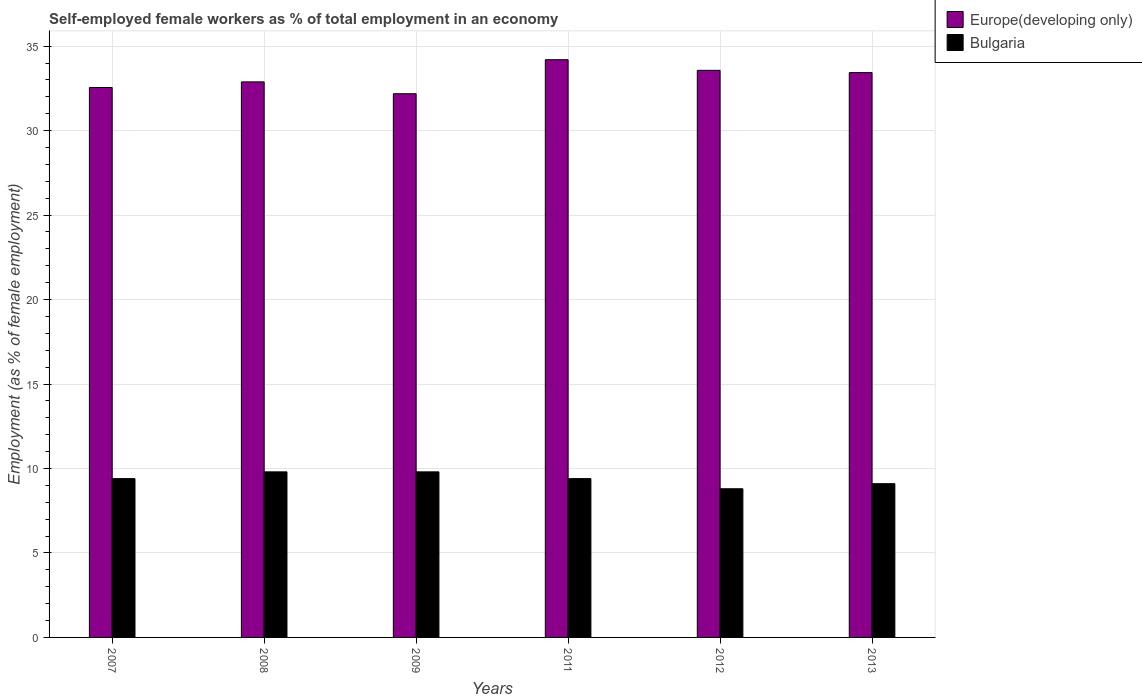How many different coloured bars are there?
Your answer should be very brief. 2. Are the number of bars per tick equal to the number of legend labels?
Make the answer very short. Yes. Are the number of bars on each tick of the X-axis equal?
Ensure brevity in your answer.  Yes. How many bars are there on the 3rd tick from the left?
Your answer should be very brief. 2. What is the label of the 6th group of bars from the left?
Your response must be concise. 2013. What is the percentage of self-employed female workers in Europe(developing only) in 2011?
Provide a short and direct response. 34.2. Across all years, what is the maximum percentage of self-employed female workers in Europe(developing only)?
Provide a succinct answer. 34.2. Across all years, what is the minimum percentage of self-employed female workers in Europe(developing only)?
Give a very brief answer. 32.18. In which year was the percentage of self-employed female workers in Bulgaria maximum?
Your answer should be very brief. 2008. What is the total percentage of self-employed female workers in Bulgaria in the graph?
Keep it short and to the point. 56.3. What is the difference between the percentage of self-employed female workers in Bulgaria in 2012 and that in 2013?
Provide a short and direct response. -0.3. What is the difference between the percentage of self-employed female workers in Bulgaria in 2008 and the percentage of self-employed female workers in Europe(developing only) in 2011?
Offer a terse response. -24.4. What is the average percentage of self-employed female workers in Bulgaria per year?
Give a very brief answer. 9.38. In the year 2008, what is the difference between the percentage of self-employed female workers in Bulgaria and percentage of self-employed female workers in Europe(developing only)?
Your answer should be very brief. -23.08. In how many years, is the percentage of self-employed female workers in Europe(developing only) greater than 8 %?
Provide a short and direct response. 6. What is the ratio of the percentage of self-employed female workers in Europe(developing only) in 2011 to that in 2012?
Your answer should be very brief. 1.02. Is the difference between the percentage of self-employed female workers in Bulgaria in 2007 and 2008 greater than the difference between the percentage of self-employed female workers in Europe(developing only) in 2007 and 2008?
Ensure brevity in your answer.  No. What is the difference between the highest and the second highest percentage of self-employed female workers in Europe(developing only)?
Provide a short and direct response. 0.63. What is the difference between the highest and the lowest percentage of self-employed female workers in Europe(developing only)?
Provide a succinct answer. 2.01. In how many years, is the percentage of self-employed female workers in Bulgaria greater than the average percentage of self-employed female workers in Bulgaria taken over all years?
Provide a short and direct response. 4. What does the 1st bar from the left in 2012 represents?
Provide a short and direct response. Europe(developing only). How many bars are there?
Provide a short and direct response. 12. Are the values on the major ticks of Y-axis written in scientific E-notation?
Keep it short and to the point. No. Does the graph contain any zero values?
Offer a terse response. No. Does the graph contain grids?
Your response must be concise. Yes. Where does the legend appear in the graph?
Keep it short and to the point. Top right. How are the legend labels stacked?
Make the answer very short. Vertical. What is the title of the graph?
Keep it short and to the point. Self-employed female workers as % of total employment in an economy. What is the label or title of the Y-axis?
Provide a short and direct response. Employment (as % of female employment). What is the Employment (as % of female employment) in Europe(developing only) in 2007?
Provide a short and direct response. 32.55. What is the Employment (as % of female employment) in Bulgaria in 2007?
Offer a very short reply. 9.4. What is the Employment (as % of female employment) in Europe(developing only) in 2008?
Give a very brief answer. 32.88. What is the Employment (as % of female employment) in Bulgaria in 2008?
Your response must be concise. 9.8. What is the Employment (as % of female employment) in Europe(developing only) in 2009?
Your answer should be very brief. 32.18. What is the Employment (as % of female employment) of Bulgaria in 2009?
Keep it short and to the point. 9.8. What is the Employment (as % of female employment) in Europe(developing only) in 2011?
Provide a succinct answer. 34.2. What is the Employment (as % of female employment) of Bulgaria in 2011?
Keep it short and to the point. 9.4. What is the Employment (as % of female employment) in Europe(developing only) in 2012?
Ensure brevity in your answer.  33.57. What is the Employment (as % of female employment) of Bulgaria in 2012?
Offer a very short reply. 8.8. What is the Employment (as % of female employment) of Europe(developing only) in 2013?
Make the answer very short. 33.43. What is the Employment (as % of female employment) in Bulgaria in 2013?
Your answer should be compact. 9.1. Across all years, what is the maximum Employment (as % of female employment) in Europe(developing only)?
Offer a terse response. 34.2. Across all years, what is the maximum Employment (as % of female employment) of Bulgaria?
Provide a short and direct response. 9.8. Across all years, what is the minimum Employment (as % of female employment) in Europe(developing only)?
Make the answer very short. 32.18. Across all years, what is the minimum Employment (as % of female employment) in Bulgaria?
Ensure brevity in your answer.  8.8. What is the total Employment (as % of female employment) of Europe(developing only) in the graph?
Provide a short and direct response. 198.81. What is the total Employment (as % of female employment) of Bulgaria in the graph?
Your answer should be very brief. 56.3. What is the difference between the Employment (as % of female employment) in Europe(developing only) in 2007 and that in 2008?
Make the answer very short. -0.33. What is the difference between the Employment (as % of female employment) in Bulgaria in 2007 and that in 2008?
Provide a short and direct response. -0.4. What is the difference between the Employment (as % of female employment) in Europe(developing only) in 2007 and that in 2009?
Offer a very short reply. 0.37. What is the difference between the Employment (as % of female employment) in Europe(developing only) in 2007 and that in 2011?
Ensure brevity in your answer.  -1.65. What is the difference between the Employment (as % of female employment) of Europe(developing only) in 2007 and that in 2012?
Keep it short and to the point. -1.02. What is the difference between the Employment (as % of female employment) in Bulgaria in 2007 and that in 2012?
Offer a very short reply. 0.6. What is the difference between the Employment (as % of female employment) in Europe(developing only) in 2007 and that in 2013?
Your answer should be compact. -0.88. What is the difference between the Employment (as % of female employment) of Bulgaria in 2007 and that in 2013?
Your answer should be very brief. 0.3. What is the difference between the Employment (as % of female employment) in Europe(developing only) in 2008 and that in 2009?
Offer a terse response. 0.7. What is the difference between the Employment (as % of female employment) of Europe(developing only) in 2008 and that in 2011?
Provide a succinct answer. -1.31. What is the difference between the Employment (as % of female employment) in Europe(developing only) in 2008 and that in 2012?
Offer a terse response. -0.68. What is the difference between the Employment (as % of female employment) of Europe(developing only) in 2008 and that in 2013?
Offer a terse response. -0.55. What is the difference between the Employment (as % of female employment) in Europe(developing only) in 2009 and that in 2011?
Your answer should be very brief. -2.01. What is the difference between the Employment (as % of female employment) of Europe(developing only) in 2009 and that in 2012?
Your answer should be very brief. -1.38. What is the difference between the Employment (as % of female employment) of Bulgaria in 2009 and that in 2012?
Make the answer very short. 1. What is the difference between the Employment (as % of female employment) of Europe(developing only) in 2009 and that in 2013?
Offer a terse response. -1.25. What is the difference between the Employment (as % of female employment) of Bulgaria in 2009 and that in 2013?
Keep it short and to the point. 0.7. What is the difference between the Employment (as % of female employment) in Europe(developing only) in 2011 and that in 2012?
Offer a terse response. 0.63. What is the difference between the Employment (as % of female employment) of Bulgaria in 2011 and that in 2012?
Your answer should be very brief. 0.6. What is the difference between the Employment (as % of female employment) of Europe(developing only) in 2011 and that in 2013?
Keep it short and to the point. 0.76. What is the difference between the Employment (as % of female employment) of Bulgaria in 2011 and that in 2013?
Ensure brevity in your answer.  0.3. What is the difference between the Employment (as % of female employment) of Europe(developing only) in 2012 and that in 2013?
Your response must be concise. 0.13. What is the difference between the Employment (as % of female employment) of Europe(developing only) in 2007 and the Employment (as % of female employment) of Bulgaria in 2008?
Offer a very short reply. 22.75. What is the difference between the Employment (as % of female employment) in Europe(developing only) in 2007 and the Employment (as % of female employment) in Bulgaria in 2009?
Ensure brevity in your answer.  22.75. What is the difference between the Employment (as % of female employment) of Europe(developing only) in 2007 and the Employment (as % of female employment) of Bulgaria in 2011?
Keep it short and to the point. 23.15. What is the difference between the Employment (as % of female employment) of Europe(developing only) in 2007 and the Employment (as % of female employment) of Bulgaria in 2012?
Offer a terse response. 23.75. What is the difference between the Employment (as % of female employment) of Europe(developing only) in 2007 and the Employment (as % of female employment) of Bulgaria in 2013?
Your answer should be compact. 23.45. What is the difference between the Employment (as % of female employment) in Europe(developing only) in 2008 and the Employment (as % of female employment) in Bulgaria in 2009?
Keep it short and to the point. 23.08. What is the difference between the Employment (as % of female employment) in Europe(developing only) in 2008 and the Employment (as % of female employment) in Bulgaria in 2011?
Your answer should be compact. 23.48. What is the difference between the Employment (as % of female employment) in Europe(developing only) in 2008 and the Employment (as % of female employment) in Bulgaria in 2012?
Offer a very short reply. 24.08. What is the difference between the Employment (as % of female employment) in Europe(developing only) in 2008 and the Employment (as % of female employment) in Bulgaria in 2013?
Your answer should be compact. 23.78. What is the difference between the Employment (as % of female employment) in Europe(developing only) in 2009 and the Employment (as % of female employment) in Bulgaria in 2011?
Provide a succinct answer. 22.78. What is the difference between the Employment (as % of female employment) of Europe(developing only) in 2009 and the Employment (as % of female employment) of Bulgaria in 2012?
Your answer should be compact. 23.38. What is the difference between the Employment (as % of female employment) of Europe(developing only) in 2009 and the Employment (as % of female employment) of Bulgaria in 2013?
Offer a very short reply. 23.08. What is the difference between the Employment (as % of female employment) of Europe(developing only) in 2011 and the Employment (as % of female employment) of Bulgaria in 2012?
Your answer should be very brief. 25.4. What is the difference between the Employment (as % of female employment) of Europe(developing only) in 2011 and the Employment (as % of female employment) of Bulgaria in 2013?
Give a very brief answer. 25.1. What is the difference between the Employment (as % of female employment) in Europe(developing only) in 2012 and the Employment (as % of female employment) in Bulgaria in 2013?
Your answer should be compact. 24.47. What is the average Employment (as % of female employment) of Europe(developing only) per year?
Keep it short and to the point. 33.13. What is the average Employment (as % of female employment) in Bulgaria per year?
Give a very brief answer. 9.38. In the year 2007, what is the difference between the Employment (as % of female employment) of Europe(developing only) and Employment (as % of female employment) of Bulgaria?
Offer a terse response. 23.15. In the year 2008, what is the difference between the Employment (as % of female employment) in Europe(developing only) and Employment (as % of female employment) in Bulgaria?
Give a very brief answer. 23.08. In the year 2009, what is the difference between the Employment (as % of female employment) in Europe(developing only) and Employment (as % of female employment) in Bulgaria?
Make the answer very short. 22.38. In the year 2011, what is the difference between the Employment (as % of female employment) in Europe(developing only) and Employment (as % of female employment) in Bulgaria?
Make the answer very short. 24.8. In the year 2012, what is the difference between the Employment (as % of female employment) of Europe(developing only) and Employment (as % of female employment) of Bulgaria?
Make the answer very short. 24.77. In the year 2013, what is the difference between the Employment (as % of female employment) of Europe(developing only) and Employment (as % of female employment) of Bulgaria?
Provide a succinct answer. 24.33. What is the ratio of the Employment (as % of female employment) of Bulgaria in 2007 to that in 2008?
Make the answer very short. 0.96. What is the ratio of the Employment (as % of female employment) in Europe(developing only) in 2007 to that in 2009?
Offer a very short reply. 1.01. What is the ratio of the Employment (as % of female employment) in Bulgaria in 2007 to that in 2009?
Give a very brief answer. 0.96. What is the ratio of the Employment (as % of female employment) of Europe(developing only) in 2007 to that in 2011?
Keep it short and to the point. 0.95. What is the ratio of the Employment (as % of female employment) of Bulgaria in 2007 to that in 2011?
Provide a short and direct response. 1. What is the ratio of the Employment (as % of female employment) of Europe(developing only) in 2007 to that in 2012?
Provide a short and direct response. 0.97. What is the ratio of the Employment (as % of female employment) in Bulgaria in 2007 to that in 2012?
Make the answer very short. 1.07. What is the ratio of the Employment (as % of female employment) in Europe(developing only) in 2007 to that in 2013?
Your response must be concise. 0.97. What is the ratio of the Employment (as % of female employment) of Bulgaria in 2007 to that in 2013?
Your answer should be compact. 1.03. What is the ratio of the Employment (as % of female employment) in Europe(developing only) in 2008 to that in 2009?
Provide a short and direct response. 1.02. What is the ratio of the Employment (as % of female employment) in Bulgaria in 2008 to that in 2009?
Provide a succinct answer. 1. What is the ratio of the Employment (as % of female employment) in Europe(developing only) in 2008 to that in 2011?
Your answer should be compact. 0.96. What is the ratio of the Employment (as % of female employment) of Bulgaria in 2008 to that in 2011?
Provide a short and direct response. 1.04. What is the ratio of the Employment (as % of female employment) of Europe(developing only) in 2008 to that in 2012?
Offer a terse response. 0.98. What is the ratio of the Employment (as % of female employment) of Bulgaria in 2008 to that in 2012?
Your response must be concise. 1.11. What is the ratio of the Employment (as % of female employment) of Europe(developing only) in 2008 to that in 2013?
Make the answer very short. 0.98. What is the ratio of the Employment (as % of female employment) in Europe(developing only) in 2009 to that in 2011?
Provide a short and direct response. 0.94. What is the ratio of the Employment (as % of female employment) of Bulgaria in 2009 to that in 2011?
Your response must be concise. 1.04. What is the ratio of the Employment (as % of female employment) of Europe(developing only) in 2009 to that in 2012?
Your answer should be very brief. 0.96. What is the ratio of the Employment (as % of female employment) in Bulgaria in 2009 to that in 2012?
Give a very brief answer. 1.11. What is the ratio of the Employment (as % of female employment) in Europe(developing only) in 2009 to that in 2013?
Keep it short and to the point. 0.96. What is the ratio of the Employment (as % of female employment) of Europe(developing only) in 2011 to that in 2012?
Provide a short and direct response. 1.02. What is the ratio of the Employment (as % of female employment) in Bulgaria in 2011 to that in 2012?
Give a very brief answer. 1.07. What is the ratio of the Employment (as % of female employment) in Europe(developing only) in 2011 to that in 2013?
Offer a terse response. 1.02. What is the ratio of the Employment (as % of female employment) in Bulgaria in 2011 to that in 2013?
Provide a succinct answer. 1.03. What is the ratio of the Employment (as % of female employment) of Europe(developing only) in 2012 to that in 2013?
Provide a short and direct response. 1. What is the difference between the highest and the second highest Employment (as % of female employment) of Europe(developing only)?
Your answer should be compact. 0.63. What is the difference between the highest and the second highest Employment (as % of female employment) in Bulgaria?
Your answer should be compact. 0. What is the difference between the highest and the lowest Employment (as % of female employment) in Europe(developing only)?
Offer a terse response. 2.01. What is the difference between the highest and the lowest Employment (as % of female employment) in Bulgaria?
Keep it short and to the point. 1. 